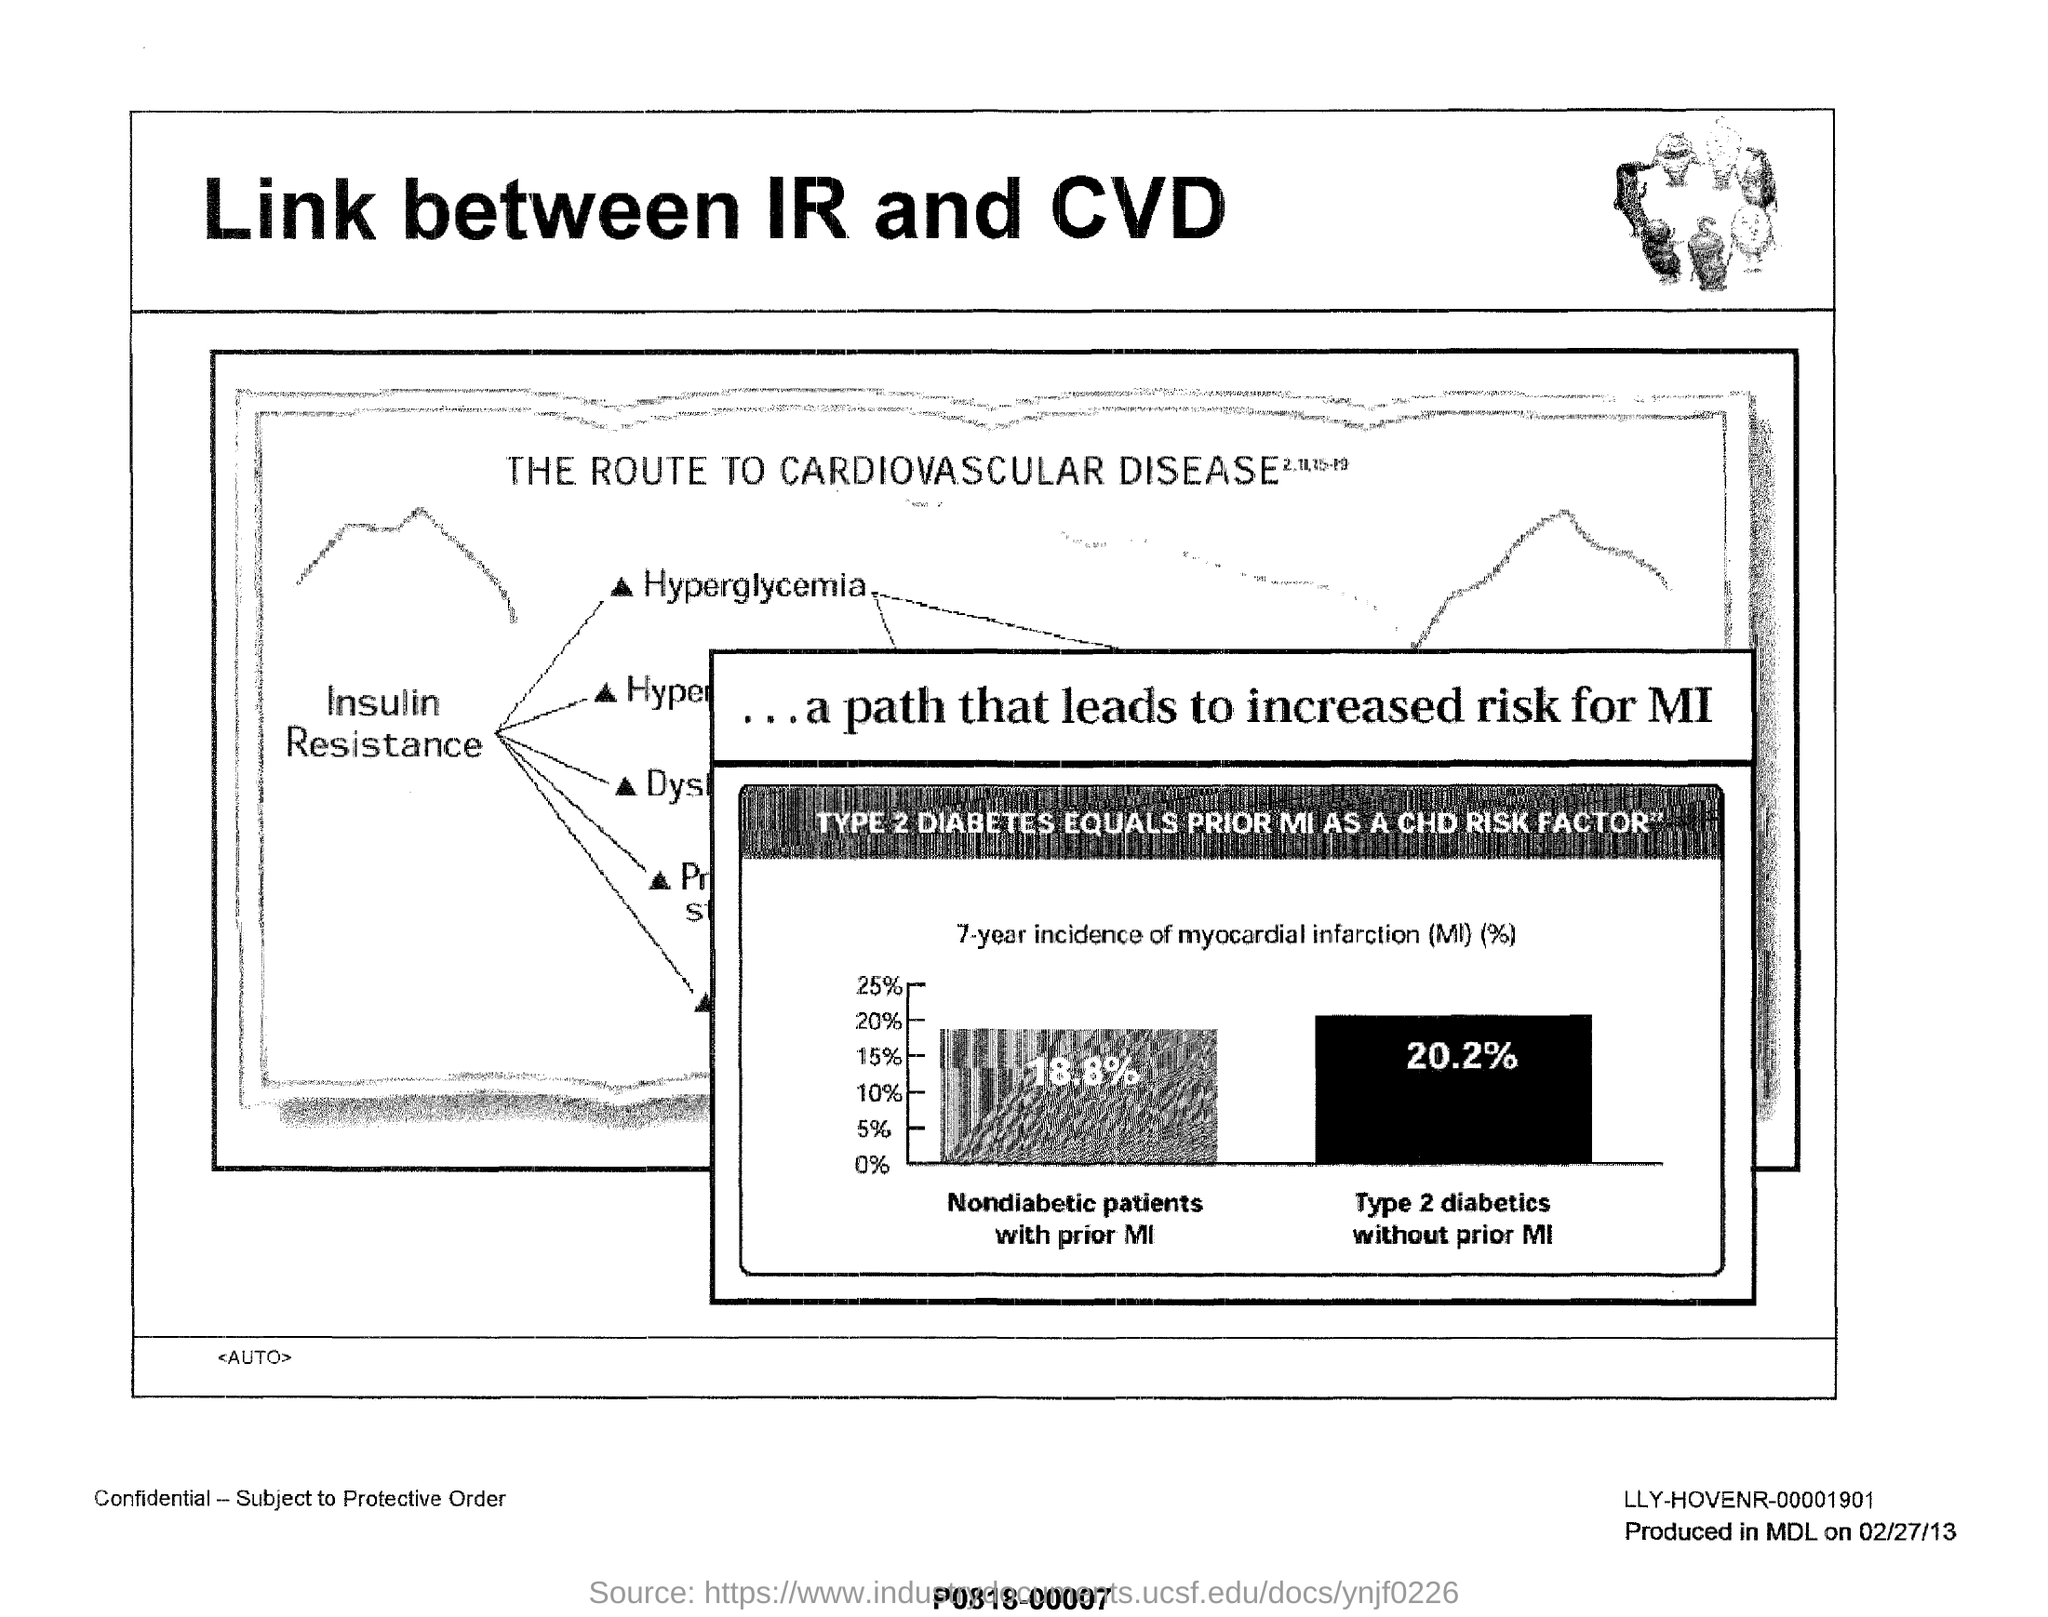Heading of the document?
Offer a terse response. LINK BETWEEN IR AND CVD. What is the percentage of Nondiabetic patients with prior MI?
Provide a short and direct response. 18.8%. 